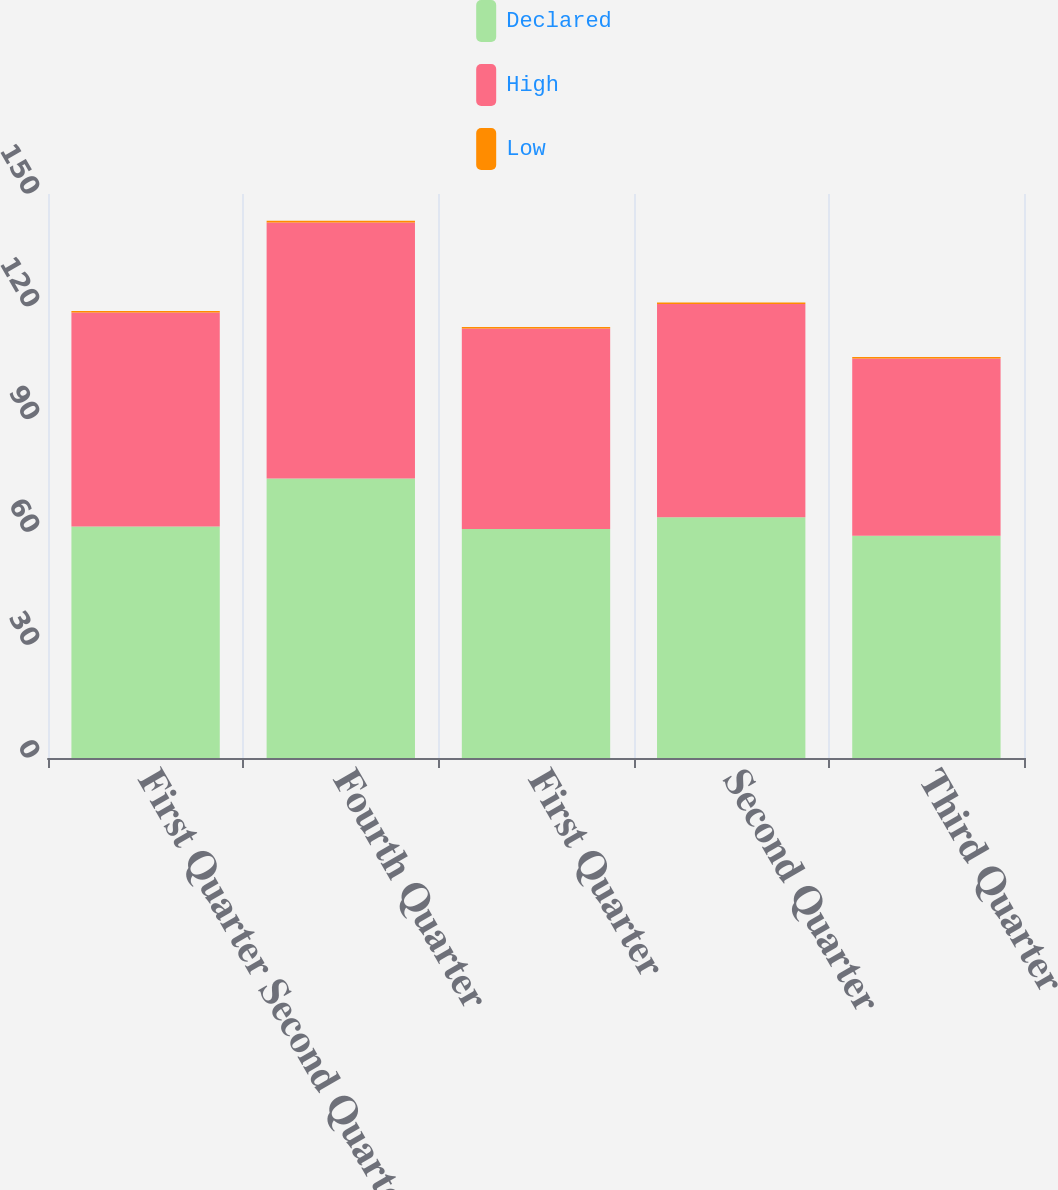Convert chart to OTSL. <chart><loc_0><loc_0><loc_500><loc_500><stacked_bar_chart><ecel><fcel>First Quarter Second Quarter<fcel>Fourth Quarter<fcel>First Quarter<fcel>Second Quarter<fcel>Third Quarter<nl><fcel>Declared<fcel>61.59<fcel>74.33<fcel>60.92<fcel>64.05<fcel>59.11<nl><fcel>High<fcel>56.87<fcel>68.07<fcel>53.33<fcel>56.68<fcel>47.12<nl><fcel>Low<fcel>0.41<fcel>0.46<fcel>0.36<fcel>0.41<fcel>0.41<nl></chart> 